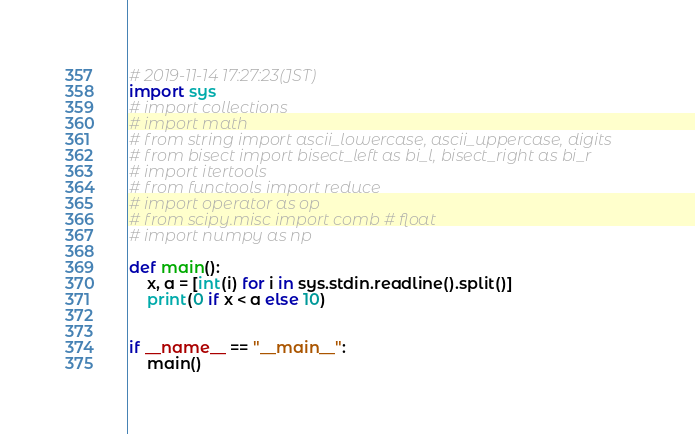Convert code to text. <code><loc_0><loc_0><loc_500><loc_500><_Python_># 2019-11-14 17:27:23(JST)
import sys
# import collections
# import math
# from string import ascii_lowercase, ascii_uppercase, digits
# from bisect import bisect_left as bi_l, bisect_right as bi_r
# import itertools
# from functools import reduce
# import operator as op
# from scipy.misc import comb # float
# import numpy as np 

def main():
    x, a = [int(i) for i in sys.stdin.readline().split()]
    print(0 if x < a else 10)


if __name__ == "__main__":
    main()
</code> 